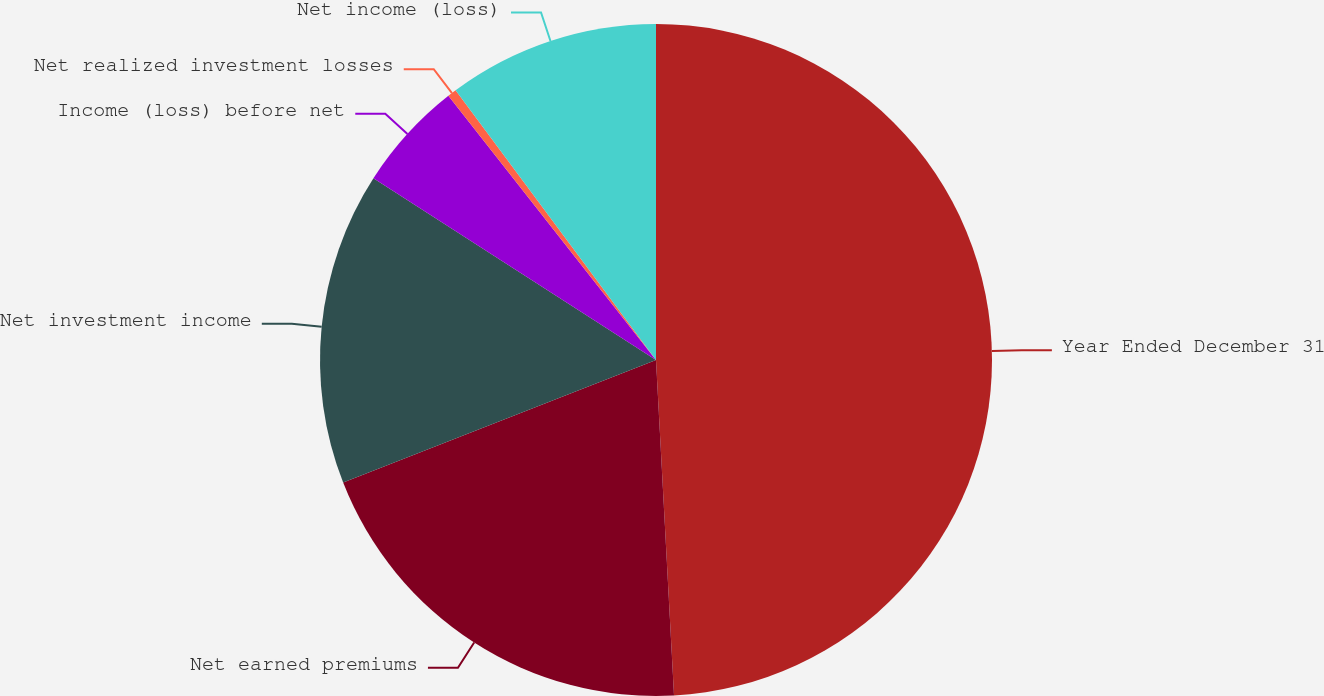<chart> <loc_0><loc_0><loc_500><loc_500><pie_chart><fcel>Year Ended December 31<fcel>Net earned premiums<fcel>Net investment income<fcel>Income (loss) before net<fcel>Net realized investment losses<fcel>Net income (loss)<nl><fcel>49.14%<fcel>19.91%<fcel>15.04%<fcel>5.3%<fcel>0.43%<fcel>10.17%<nl></chart> 